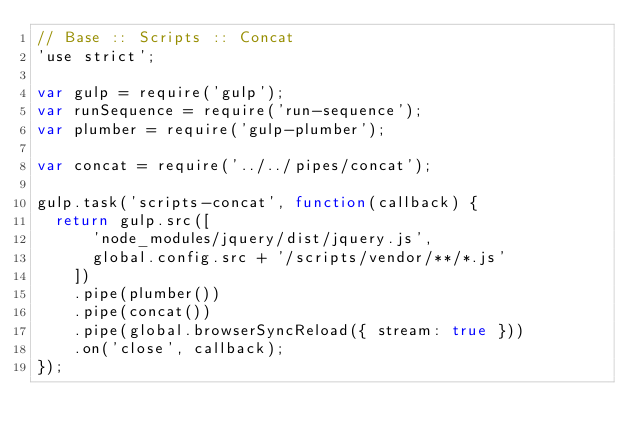<code> <loc_0><loc_0><loc_500><loc_500><_JavaScript_>// Base :: Scripts :: Concat
'use strict';

var gulp = require('gulp');
var runSequence = require('run-sequence');
var plumber = require('gulp-plumber');

var concat = require('../../pipes/concat');

gulp.task('scripts-concat', function(callback) {
  return gulp.src([
      'node_modules/jquery/dist/jquery.js',
      global.config.src + '/scripts/vendor/**/*.js'
    ])
    .pipe(plumber())
    .pipe(concat())
    .pipe(global.browserSyncReload({ stream: true }))
    .on('close', callback);
});
</code> 